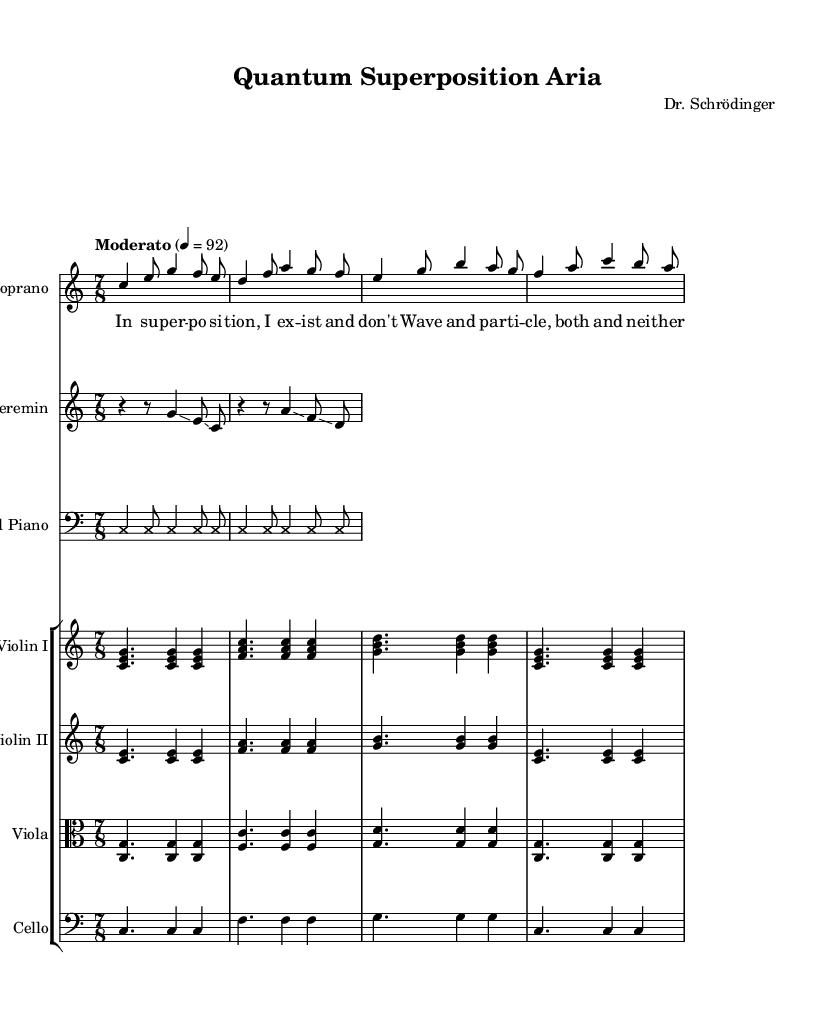What is the key signature of this music? The key signature indicated at the beginning of the piece shows that it is in C major, which has no sharps or flats. This can be identified by the absence of any sharps or flats on the staff.
Answer: C major What is the time signature of this piece? The time signature indicated at the beginning of the music is 7/8, which means there are seven beats in a measure, and the eighth note receives one beat. This is shown in the opening section of the score right after the key signature.
Answer: 7/8 What is the tempo of this opera segment? The tempo marking shows "Moderato" with a metronomic indication of 4 = 92, meaning the quarter note is to be played at a speed of 92 beats per minute. This is noted prominently at the beginning of the score.
Answer: Moderato How many measures are in the soprano's vocal line? By counting the distinct measures in the soprano voice part, it can be observed that there are eight measures in total. Each measure is separated clearly by vertical lines, making them easy to identify.
Answer: 8 measures Which instruments accompany the soprano in this piece? The instruments accompanying the soprano include a Theremin and a Prepared Piano. This information can be gathered from the staff parts, where the soprano staff is followed by the staff for each of these instruments.
Answer: Theremin, Prepared Piano What is the main theme of the soprano's lyrics? The lyrics express themes of superposition and duality, referencing concepts from quantum mechanics, specifically "Wave and particle, both and neither." This reflects the foundational idea of uncertainty in quantum theory.
Answer: Superposition, wave-particle duality Which technique is used in the Prepared Piano part? The Prepared Piano part is indicated with a notation that suggests the use of "cross" note heads, which is typical for prepared piano where objects are placed on the strings to create unique sounds. This is specified in the instructions within the prepared piano notation.
Answer: Cross note heads 